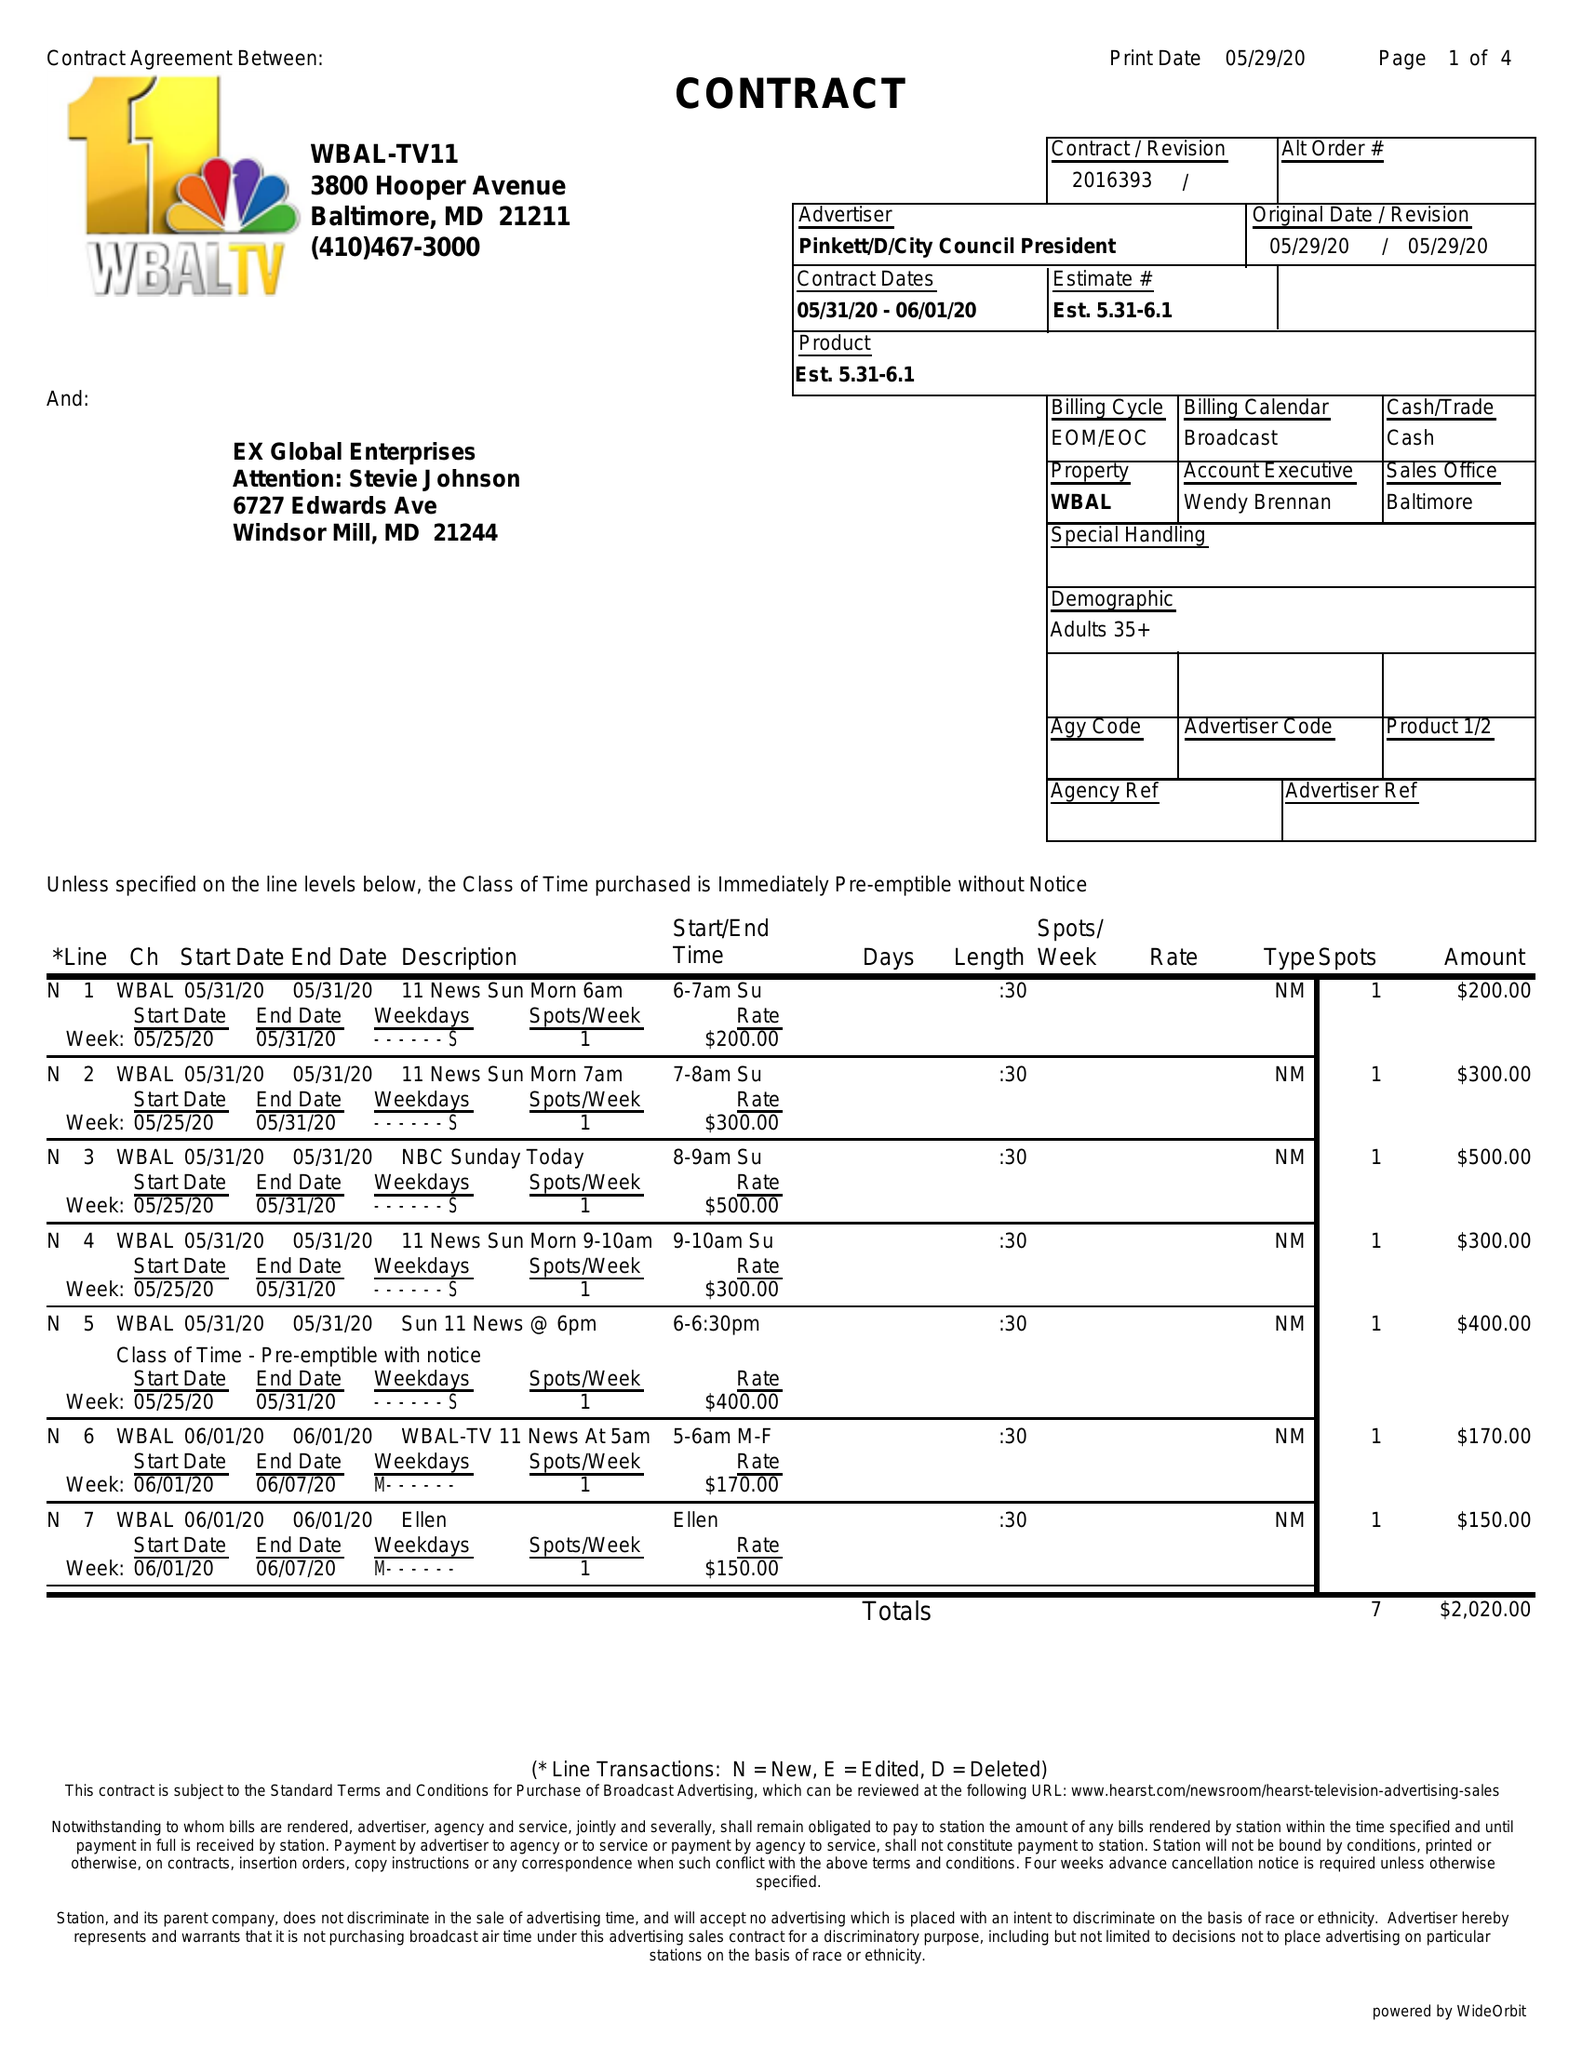What is the value for the contract_num?
Answer the question using a single word or phrase. 2016393 